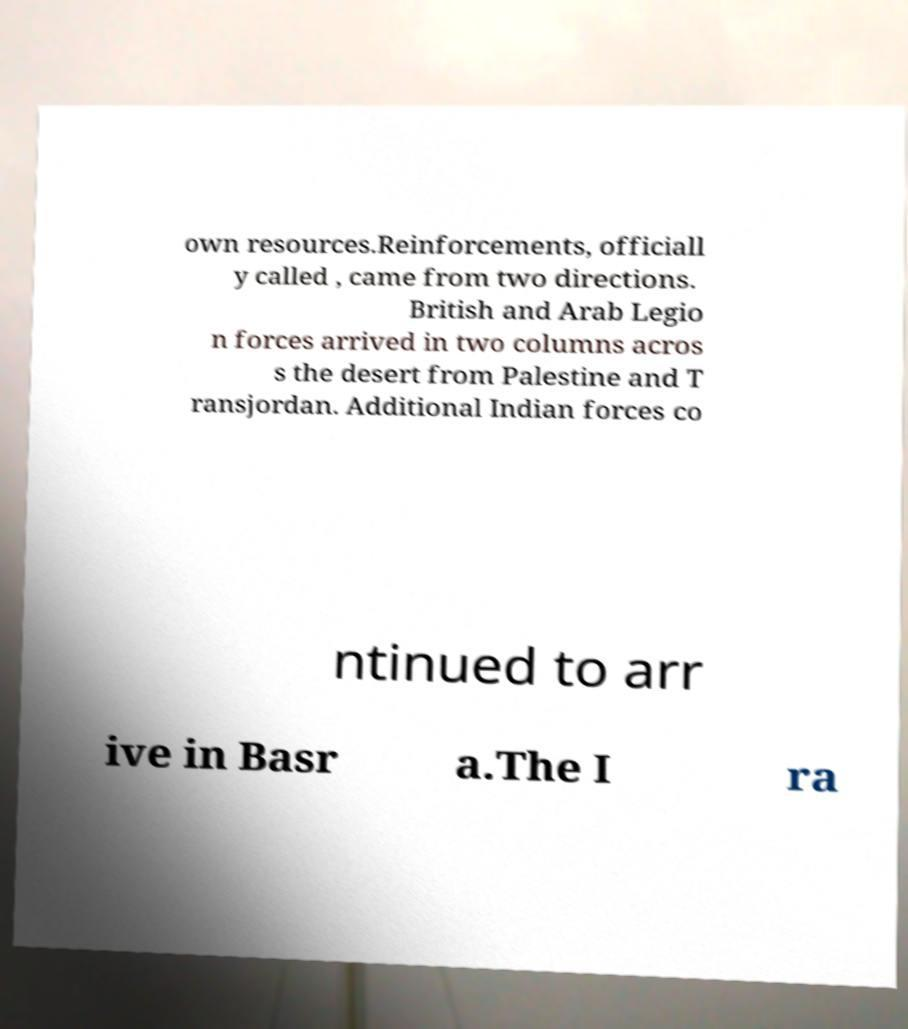Please read and relay the text visible in this image. What does it say? own resources.Reinforcements, officiall y called , came from two directions. British and Arab Legio n forces arrived in two columns acros s the desert from Palestine and T ransjordan. Additional Indian forces co ntinued to arr ive in Basr a.The I ra 